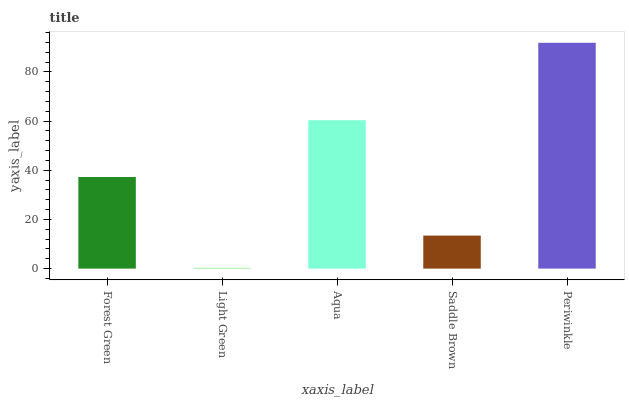Is Light Green the minimum?
Answer yes or no. Yes. Is Periwinkle the maximum?
Answer yes or no. Yes. Is Aqua the minimum?
Answer yes or no. No. Is Aqua the maximum?
Answer yes or no. No. Is Aqua greater than Light Green?
Answer yes or no. Yes. Is Light Green less than Aqua?
Answer yes or no. Yes. Is Light Green greater than Aqua?
Answer yes or no. No. Is Aqua less than Light Green?
Answer yes or no. No. Is Forest Green the high median?
Answer yes or no. Yes. Is Forest Green the low median?
Answer yes or no. Yes. Is Aqua the high median?
Answer yes or no. No. Is Aqua the low median?
Answer yes or no. No. 